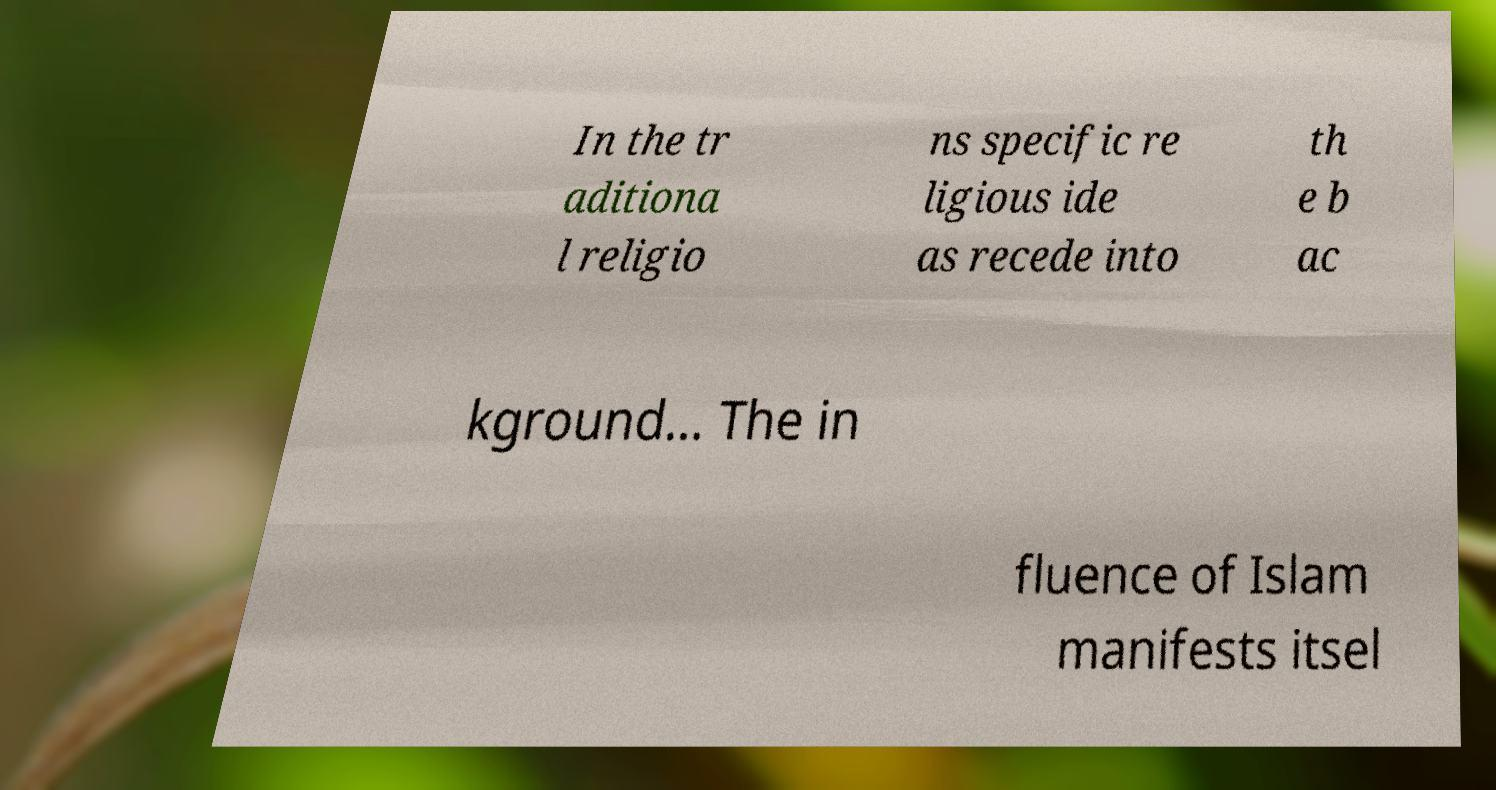Can you read and provide the text displayed in the image?This photo seems to have some interesting text. Can you extract and type it out for me? In the tr aditiona l religio ns specific re ligious ide as recede into th e b ac kground... The in fluence of Islam manifests itsel 